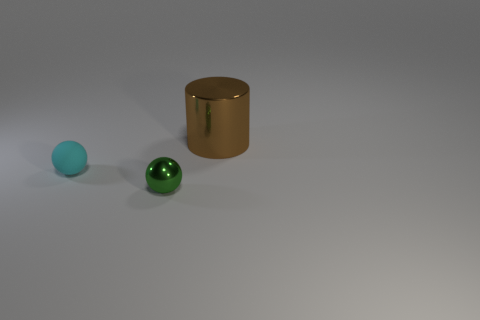Add 1 large brown metallic cylinders. How many objects exist? 4 Subtract all cylinders. How many objects are left? 2 Subtract all tiny green things. Subtract all large shiny cylinders. How many objects are left? 1 Add 1 big things. How many big things are left? 2 Add 3 large blue blocks. How many large blue blocks exist? 3 Subtract 0 green cubes. How many objects are left? 3 